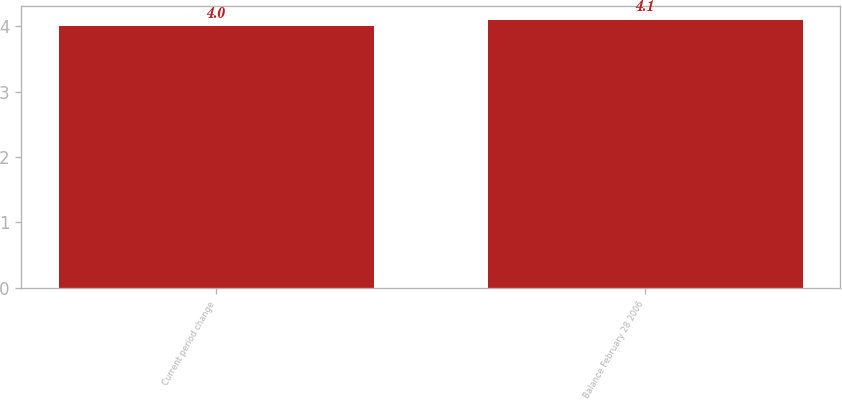Convert chart to OTSL. <chart><loc_0><loc_0><loc_500><loc_500><bar_chart><fcel>Current period change<fcel>Balance February 28 2006<nl><fcel>4<fcel>4.1<nl></chart> 